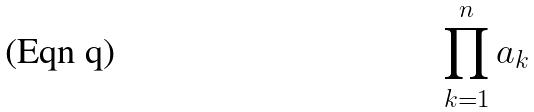Convert formula to latex. <formula><loc_0><loc_0><loc_500><loc_500>\prod _ { k = 1 } ^ { n } a _ { k }</formula> 